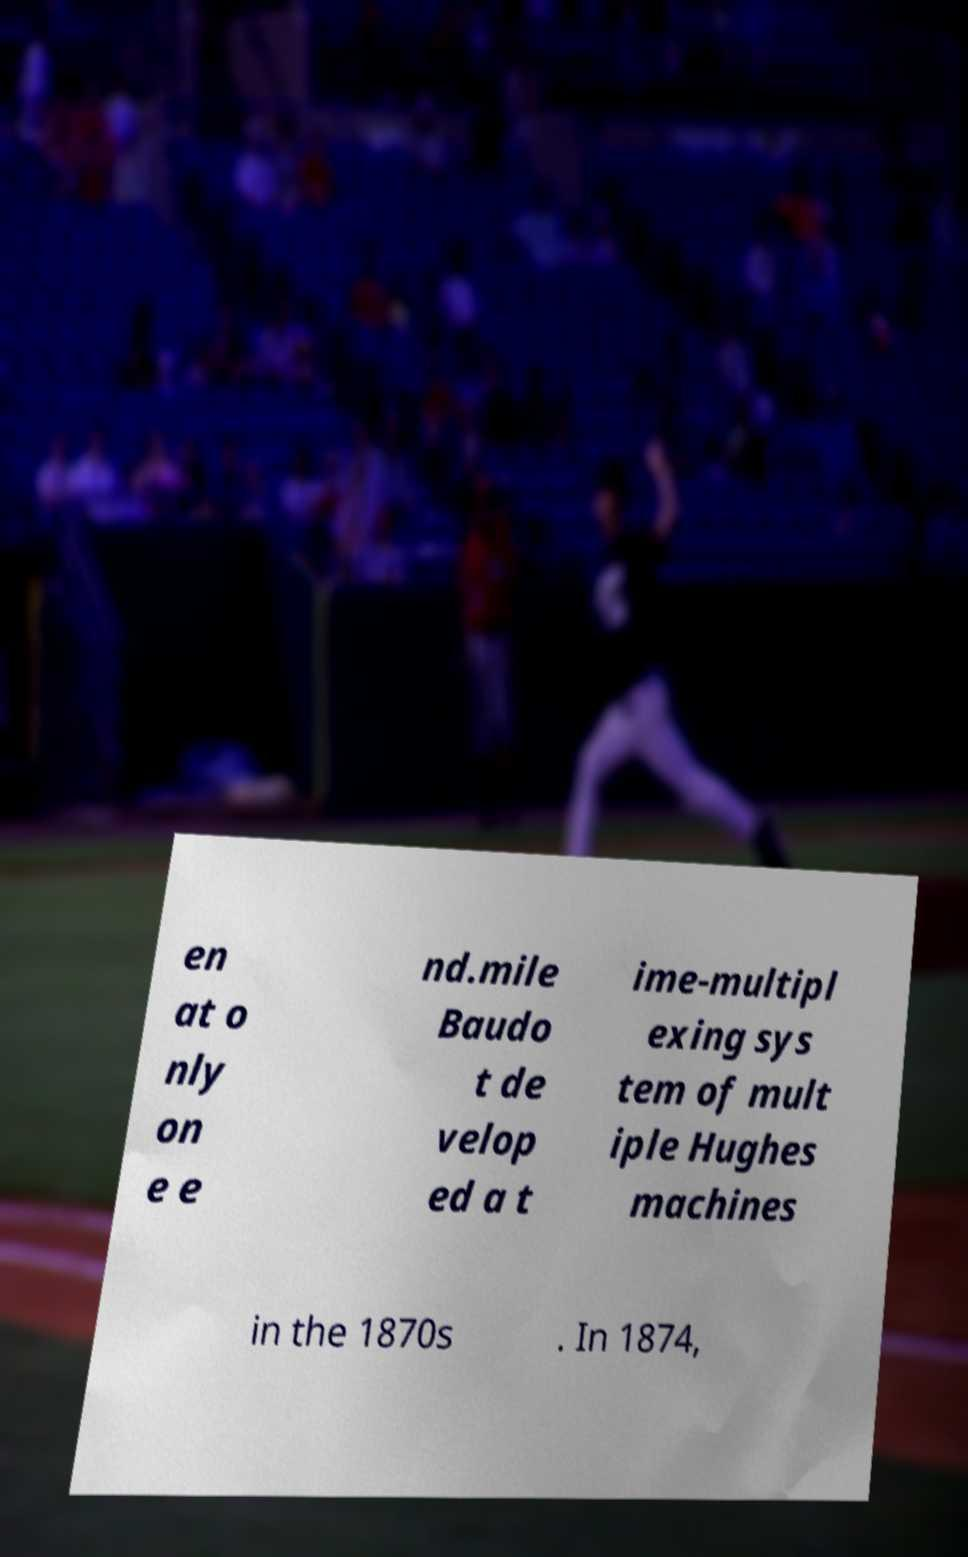Please read and relay the text visible in this image. What does it say? en at o nly on e e nd.mile Baudo t de velop ed a t ime-multipl exing sys tem of mult iple Hughes machines in the 1870s . In 1874, 